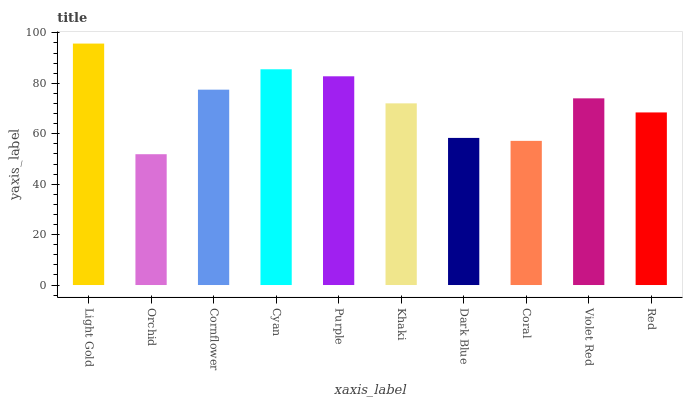Is Orchid the minimum?
Answer yes or no. Yes. Is Light Gold the maximum?
Answer yes or no. Yes. Is Cornflower the minimum?
Answer yes or no. No. Is Cornflower the maximum?
Answer yes or no. No. Is Cornflower greater than Orchid?
Answer yes or no. Yes. Is Orchid less than Cornflower?
Answer yes or no. Yes. Is Orchid greater than Cornflower?
Answer yes or no. No. Is Cornflower less than Orchid?
Answer yes or no. No. Is Violet Red the high median?
Answer yes or no. Yes. Is Khaki the low median?
Answer yes or no. Yes. Is Dark Blue the high median?
Answer yes or no. No. Is Red the low median?
Answer yes or no. No. 